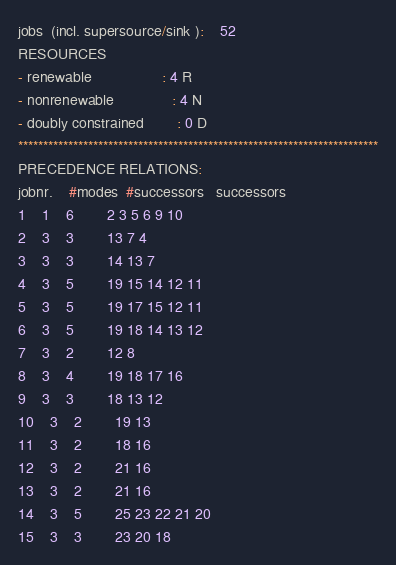<code> <loc_0><loc_0><loc_500><loc_500><_ObjectiveC_>jobs  (incl. supersource/sink ):	52
RESOURCES
- renewable                 : 4 R
- nonrenewable              : 4 N
- doubly constrained        : 0 D
************************************************************************
PRECEDENCE RELATIONS:
jobnr.    #modes  #successors   successors
1	1	6		2 3 5 6 9 10 
2	3	3		13 7 4 
3	3	3		14 13 7 
4	3	5		19 15 14 12 11 
5	3	5		19 17 15 12 11 
6	3	5		19 18 14 13 12 
7	3	2		12 8 
8	3	4		19 18 17 16 
9	3	3		18 13 12 
10	3	2		19 13 
11	3	2		18 16 
12	3	2		21 16 
13	3	2		21 16 
14	3	5		25 23 22 21 20 
15	3	3		23 20 18 </code> 